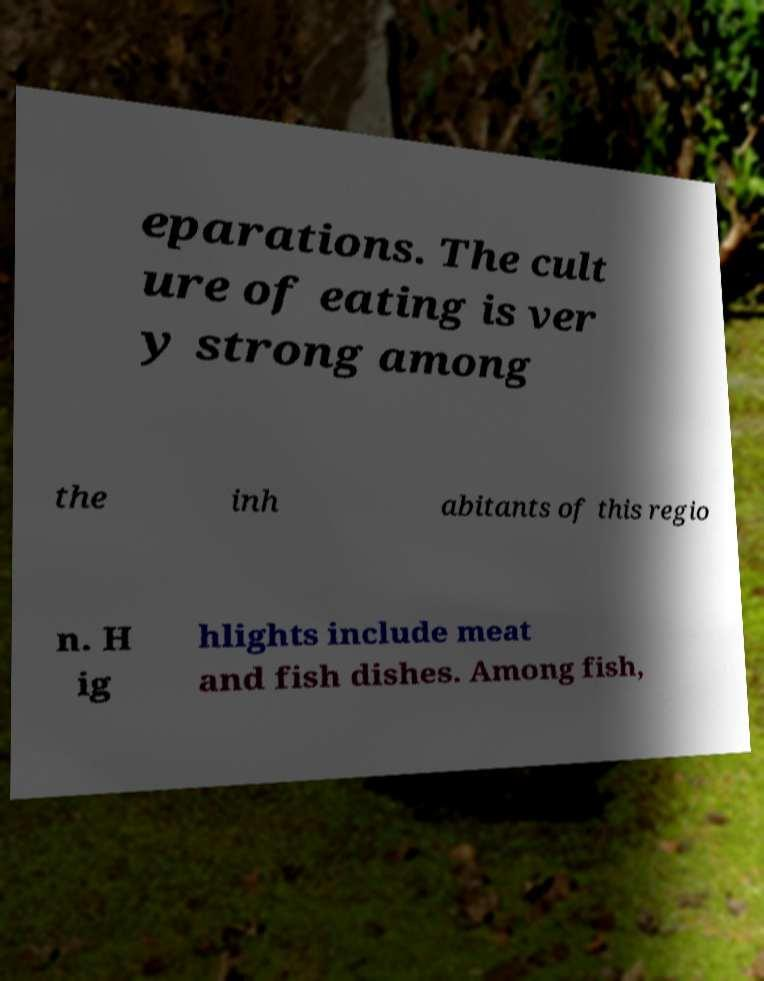For documentation purposes, I need the text within this image transcribed. Could you provide that? eparations. The cult ure of eating is ver y strong among the inh abitants of this regio n. H ig hlights include meat and fish dishes. Among fish, 